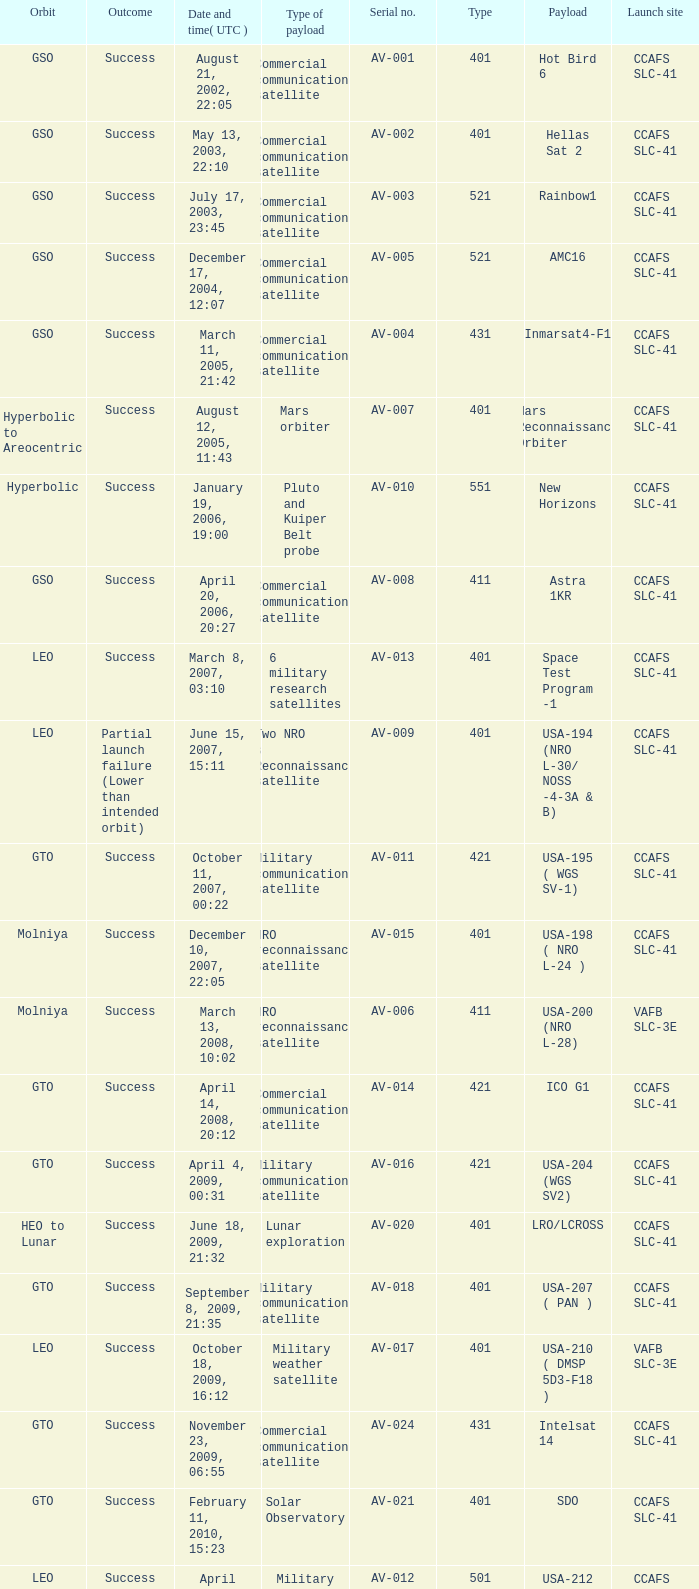When was the payload of Commercial Communications Satellite amc16? December 17, 2004, 12:07. 